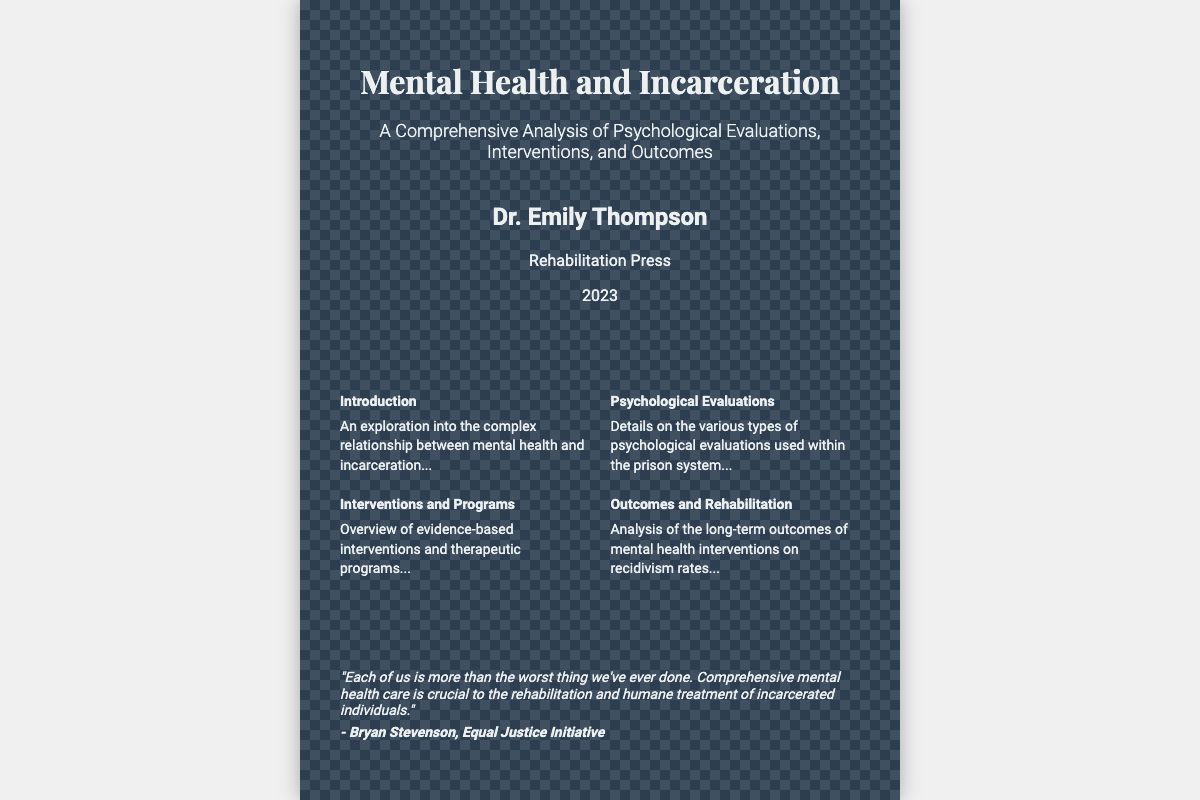What is the title of the book? The title of the book is prominently displayed at the top of the cover.
Answer: Mental Health and Incarceration Who is the author of the book? The author’s name is listed below the book title.
Answer: Dr. Emily Thompson What year was the book published? The publication date is provided near the author’s name.
Answer: 2023 What is the subtitle of the book? The subtitle is mentioned just below the title, adding context to the main theme.
Answer: A Comprehensive Analysis of Psychological Evaluations, Interventions, and Outcomes Which publishing company produced the book? The publisher’s name is indicated at the bottom of the cover.
Answer: Rehabilitation Press What section covers psychological evaluations? The section about psychological evaluations is clearly labeled in the content area.
Answer: Psychological Evaluations What is a focus of the "Interventions and Programs" section? This section discusses the nature of the programs provided in the document.
Answer: Evidence-based interventions and therapeutic programs What does the author suggest about mental health care for incarcerated individuals? The quote emphasizes a key belief about rehabilitation and humane treatment highlighted on the cover.
Answer: Comprehensive mental health care What is the theme of the "Outcomes and Rehabilitation" section? This section analyzes how mental health interventions impact a specific outcome in incarcerated individuals.
Answer: Recidivism rates 